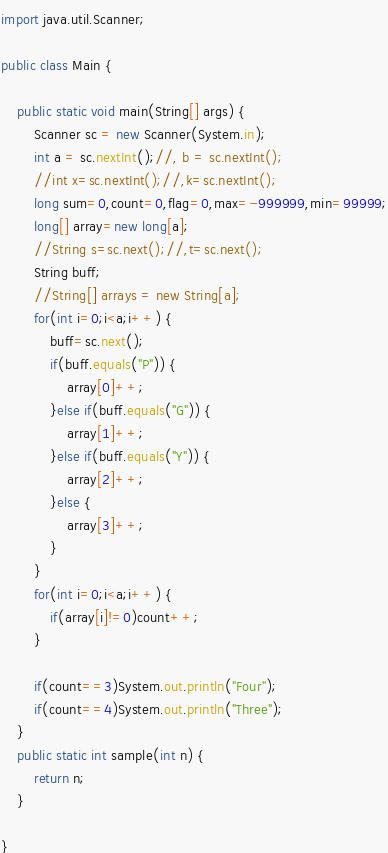<code> <loc_0><loc_0><loc_500><loc_500><_Java_>import java.util.Scanner;

public class Main {

	public static void main(String[] args) {
		Scanner sc = new Scanner(System.in);
		int a = sc.nextInt();//, b = sc.nextInt();
		//int x=sc.nextInt();//,k=sc.nextInt();
		long sum=0,count=0,flag=0,max=-999999,min=99999;
		long[] array=new long[a];
		//String s=sc.next();//,t=sc.next();
		String buff;
		//String[] arrays = new String[a];
		for(int i=0;i<a;i++) {
			buff=sc.next();
			if(buff.equals("P")) {
				array[0]++;
			}else if(buff.equals("G")) {
				array[1]++;
			}else if(buff.equals("Y")) {
				array[2]++;
			}else {
				array[3]++;
			}
		}
		for(int i=0;i<a;i++) {
			if(array[i]!=0)count++;
		}

		if(count==3)System.out.println("Four");
		if(count==4)System.out.println("Three");
	}
	public static int sample(int n) {
		return n;
	}

}
</code> 